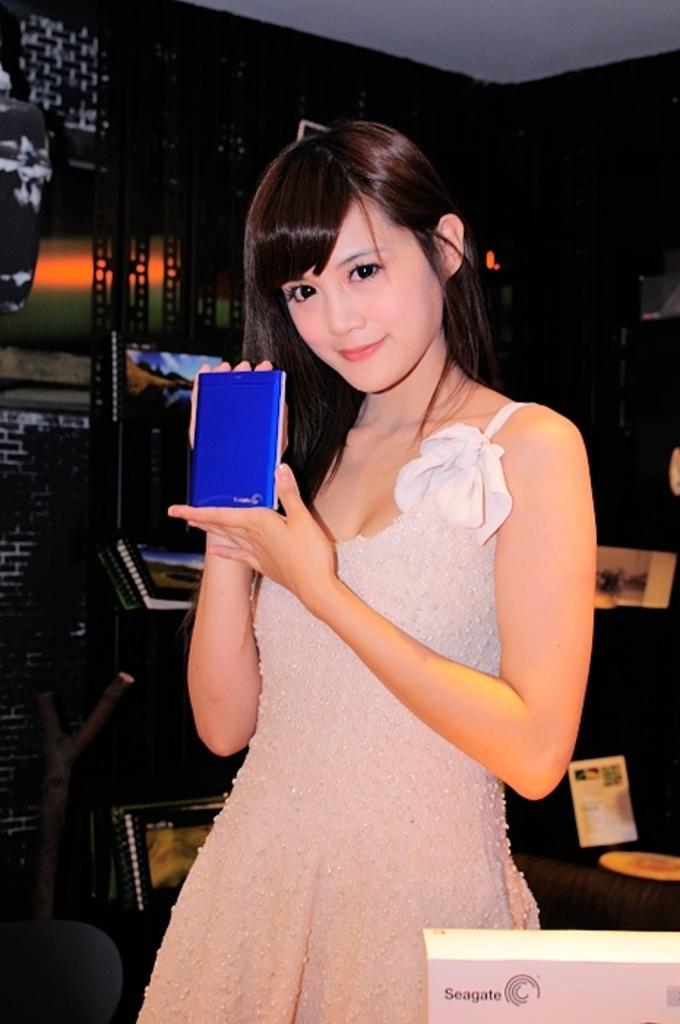Please provide a concise description of this image. In this picture I can observe a girl. She is smiling. She is holding a blue color object in her hands. In the background I can observe some albums. 